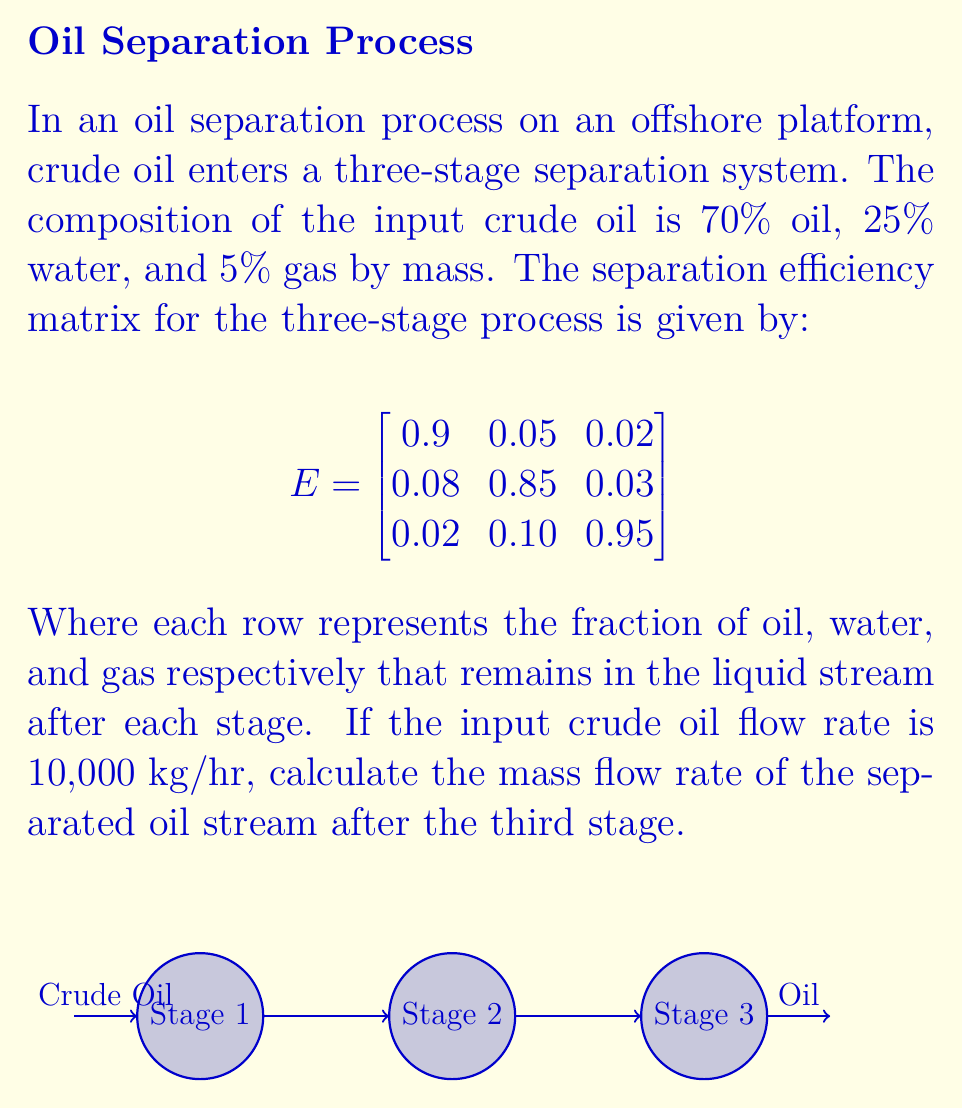Can you answer this question? Let's approach this step-by-step:

1) First, we need to calculate the initial mass flow rates of oil, water, and gas:

   Oil: $10,000 \times 0.70 = 7,000$ kg/hr
   Water: $10,000 \times 0.25 = 2,500$ kg/hr
   Gas: $10,000 \times 0.05 = 500$ kg/hr

2) We can represent this as an initial composition vector:

   $$C_0 = \begin{bmatrix} 7000 \\ 2500 \\ 500 \end{bmatrix}$$

3) To find the composition after each stage, we multiply the composition vector by the efficiency matrix:

   $$C_1 = E \times C_0$$
   $$C_2 = E \times C_1$$
   $$C_3 = E \times C_2$$

4) Let's calculate C1:

   $$C_1 = \begin{bmatrix}
   0.9 & 0.05 & 0.02 \\
   0.08 & 0.85 & 0.03 \\
   0.02 & 0.10 & 0.95
   \end{bmatrix} \times \begin{bmatrix} 7000 \\ 2500 \\ 500 \end{bmatrix}$$

   $$C_1 = \begin{bmatrix}
   6300 + 125 + 10 \\
   560 + 2125 + 15 \\
   140 + 250 + 475
   \end{bmatrix} = \begin{bmatrix} 6435 \\ 2700 \\ 865 \end{bmatrix}$$

5) Now C2:

   $$C_2 = \begin{bmatrix}
   0.9 & 0.05 & 0.02 \\
   0.08 & 0.85 & 0.03 \\
   0.02 & 0.10 & 0.95
   \end{bmatrix} \times \begin{bmatrix} 6435 \\ 2700 \\ 865 \end{bmatrix}$$

   $$C_2 = \begin{bmatrix} 5791.5 + 135 + 17.3 \\ 514.8 + 2295 + 25.95 \\ 128.7 + 270 + 821.75 \end{bmatrix} = \begin{bmatrix} 5943.8 \\ 2835.75 \\ 1220.45 \end{bmatrix}$$

6) Finally, C3:

   $$C_3 = \begin{bmatrix}
   0.9 & 0.05 & 0.02 \\
   0.08 & 0.85 & 0.03 \\
   0.02 & 0.10 & 0.95
   \end{bmatrix} \times \begin{bmatrix} 5943.8 \\ 2835.75 \\ 1220.45 \end{bmatrix}$$

   $$C_3 = \begin{bmatrix} 5349.42 + 141.79 + 24.41 \\ 475.50 + 2410.39 + 36.61 \\ 118.88 + 283.58 + 1159.43 \end{bmatrix} = \begin{bmatrix} 5515.62 \\ 2922.50 \\ 1561.89 \end{bmatrix}$$

7) The first element of C3 represents the mass flow rate of oil after the third stage.
Answer: 5515.62 kg/hr 